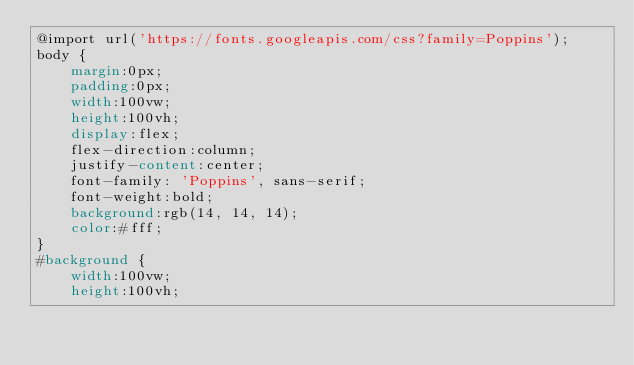Convert code to text. <code><loc_0><loc_0><loc_500><loc_500><_CSS_>@import url('https://fonts.googleapis.com/css?family=Poppins');
body {
    margin:0px;
    padding:0px;
    width:100vw;
    height:100vh;
    display:flex;
    flex-direction:column;
    justify-content:center;
    font-family: 'Poppins', sans-serif;
    font-weight:bold;
    background:rgb(14, 14, 14);
    color:#fff;
}
#background {
    width:100vw;
    height:100vh;</code> 